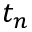<formula> <loc_0><loc_0><loc_500><loc_500>t _ { n }</formula> 